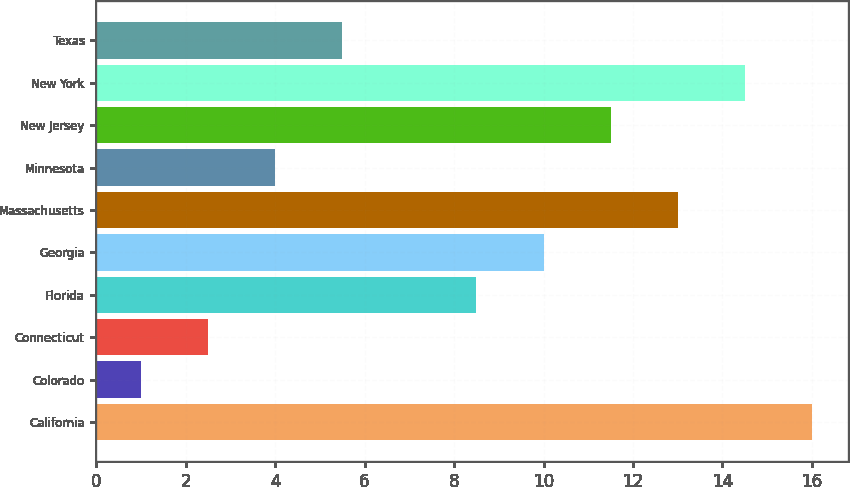Convert chart. <chart><loc_0><loc_0><loc_500><loc_500><bar_chart><fcel>California<fcel>Colorado<fcel>Connecticut<fcel>Florida<fcel>Georgia<fcel>Massachusetts<fcel>Minnesota<fcel>New Jersey<fcel>New York<fcel>Texas<nl><fcel>16<fcel>1<fcel>2.5<fcel>8.5<fcel>10<fcel>13<fcel>4<fcel>11.5<fcel>14.5<fcel>5.5<nl></chart> 